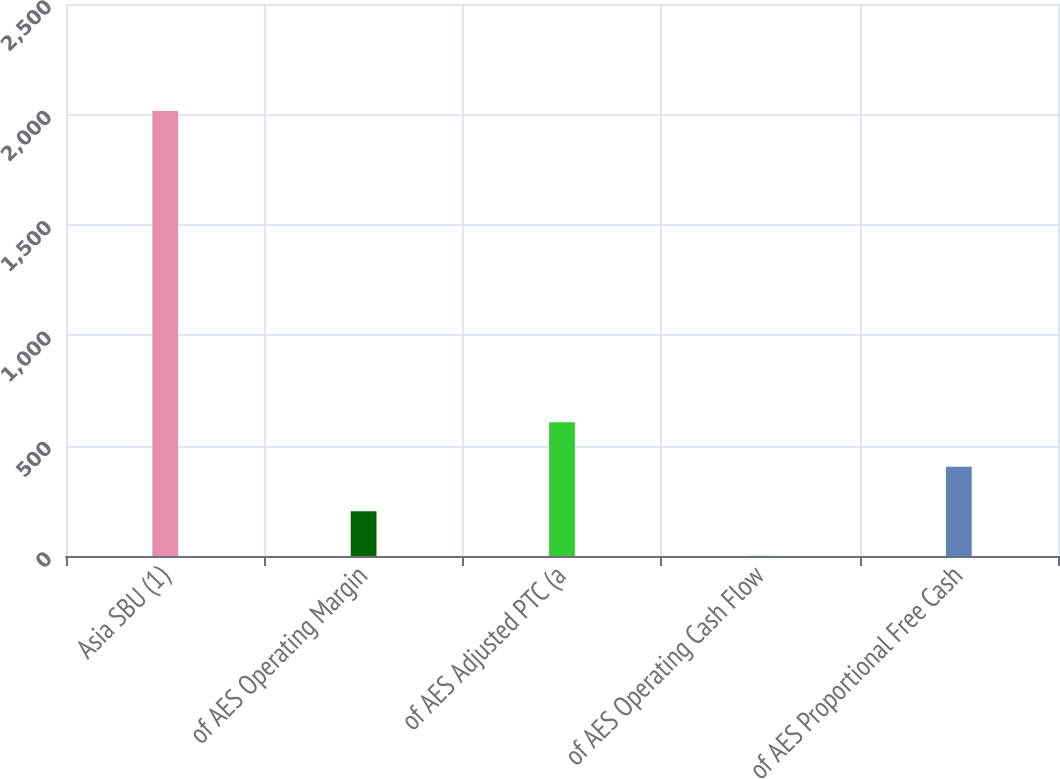Convert chart to OTSL. <chart><loc_0><loc_0><loc_500><loc_500><bar_chart><fcel>Asia SBU (1)<fcel>of AES Operating Margin<fcel>of AES Adjusted PTC (a<fcel>of AES Operating Cash Flow<fcel>of AES Proportional Free Cash<nl><fcel>2015<fcel>202.4<fcel>605.2<fcel>1<fcel>403.8<nl></chart> 